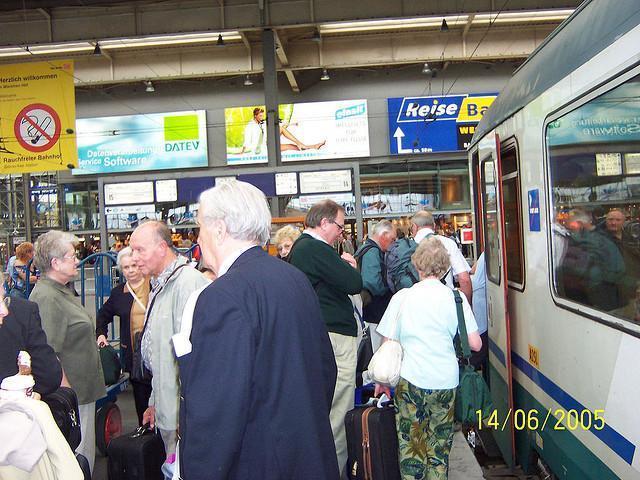How many billboards do you see?
Give a very brief answer. 3. How many suitcases can you see?
Give a very brief answer. 2. How many people are there?
Give a very brief answer. 8. 